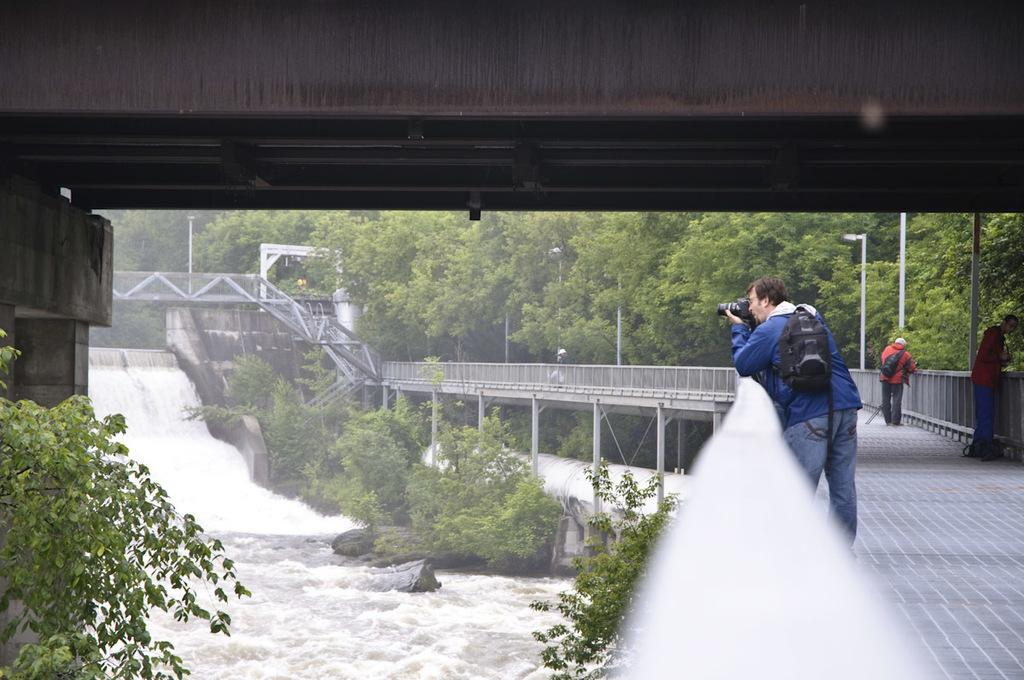How many people are in the image? There are people in the image, but the exact number is not specified. What is the man holding in the image? The man is holding a camera in the image. What else is the man carrying in the image? The man is carrying a bag in the image. What type of barrier can be seen in the image? There are fences in the image. What natural element is visible in the image? Water is visible in the image. What type of vegetation is present in the image? Trees are present in the image. What type of terrain is visible in the image? Rocks are visible in the image. What type of structure is present in the image? There is a bridge in the image. What type of vertical structures are present in the image? Poles are present in the image. What type of writing can be seen on the roots in the image? There is no writing or roots present in the image. 